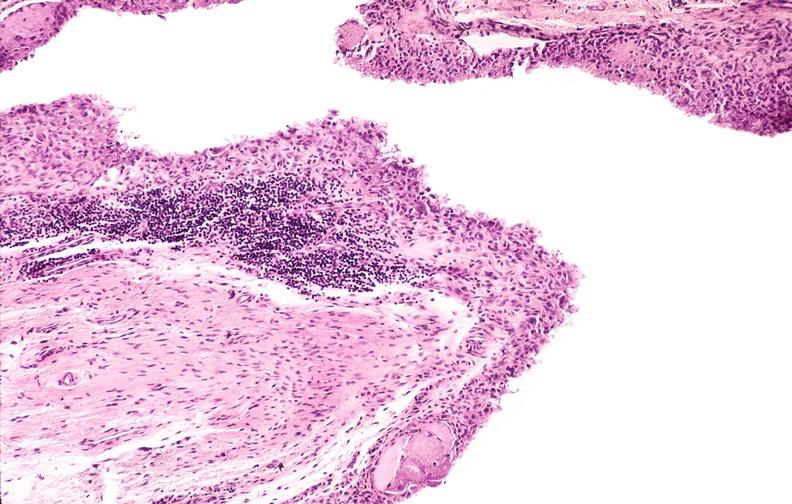s joints present?
Answer the question using a single word or phrase. Yes 